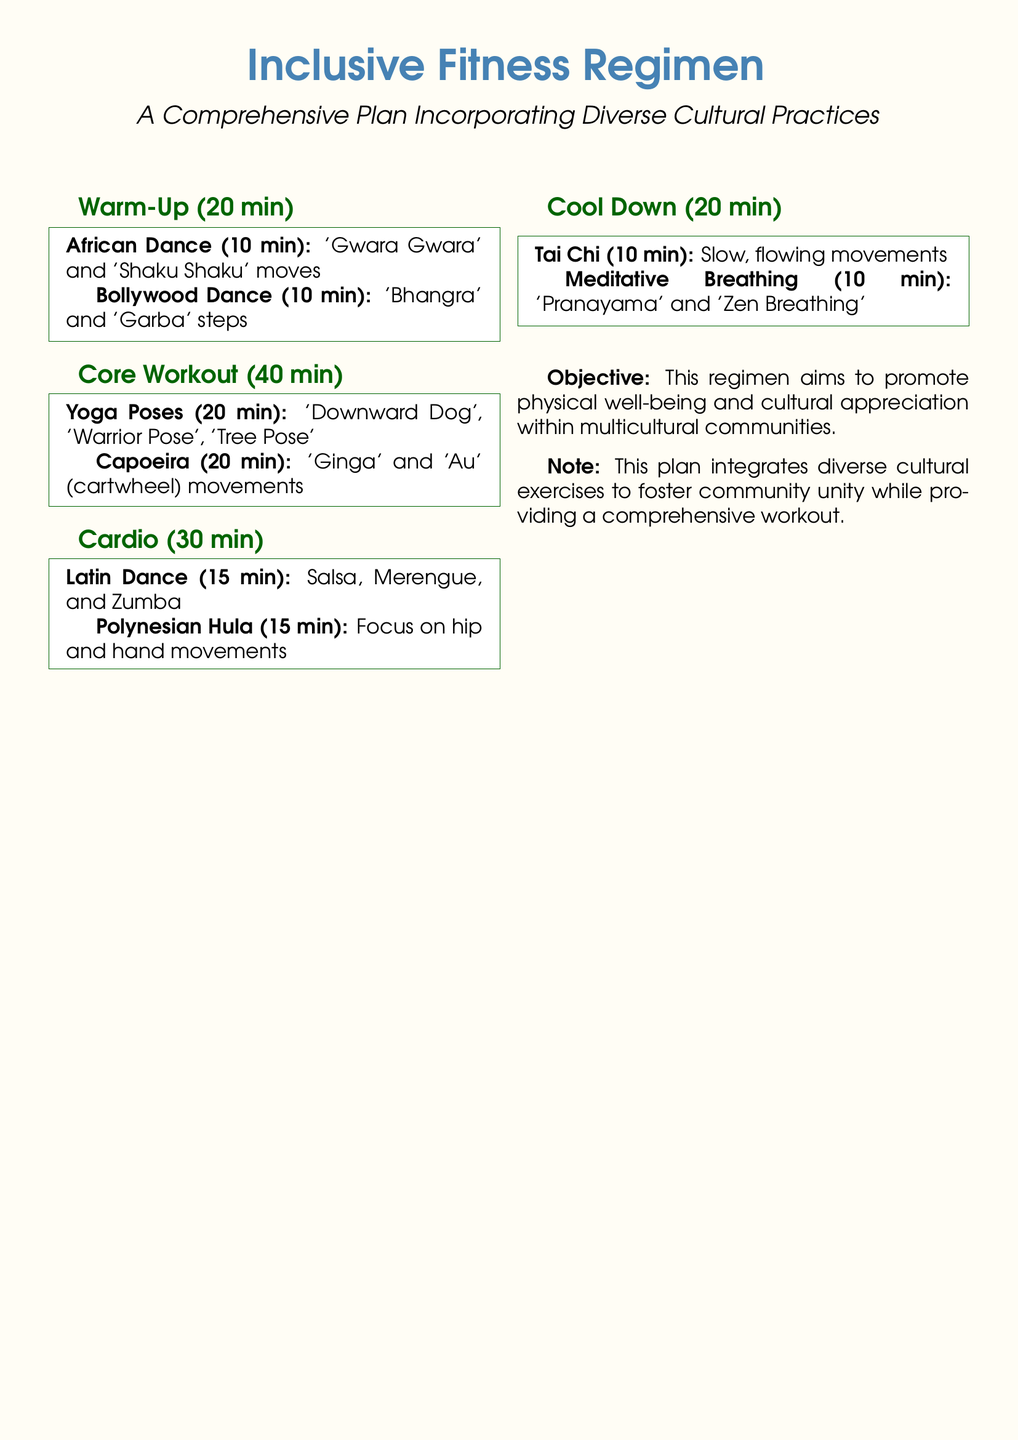What is the duration of the warm-up? The warm-up section has a duration specified in the document.
Answer: 20 min What are the two types of dance included in the warm-up? The warm-up section lists two specific dance styles that are part of the routine.
Answer: African Dance, Bollywood Dance How long is the core workout? The core workout section specifies a total duration in minutes.
Answer: 40 min Which yoga poses are included in the core workout? The core workout details the specific yoga poses incorporated.
Answer: Downward Dog, Warrior Pose, Tree Pose What type of dance is featured for cardio? The cardio section describes the types of dance exercises included in that portion of the regimen.
Answer: Latin Dance How long is the cooldown session? The cooldown section provides a specific duration for the exercises included.
Answer: 20 min What is included in the meditative breathing section? The cool down section identifies techniques used for meditative breathing.
Answer: Pranayama, Zen Breathing What is the main objective of this workout regimen? The document states the primary purpose or goal of the fitness plan.
Answer: Promote physical well-being and cultural appreciation What type of movements does Tai Chi focus on? The cool down section outlines the nature of the Tai Chi movements designed for relaxation.
Answer: Slow, flowing movements 